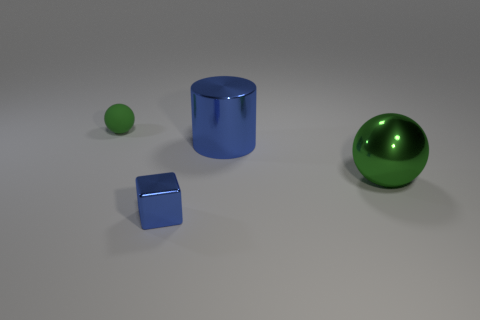What number of objects are cylinders or blue objects to the right of the blue metallic block?
Your response must be concise. 1. There is a object to the left of the blue cube; are there any green metallic spheres that are to the right of it?
Provide a succinct answer. Yes. What color is the sphere that is to the left of the big green thing?
Make the answer very short. Green. Is the number of green matte objects that are to the right of the blue block the same as the number of metallic things?
Provide a short and direct response. No. What is the shape of the object that is behind the big ball and right of the tiny blue shiny block?
Provide a succinct answer. Cylinder. The other matte object that is the same shape as the big green object is what color?
Your answer should be very brief. Green. Is there any other thing that has the same color as the cylinder?
Your answer should be compact. Yes. What shape is the object to the left of the metal thing that is in front of the ball in front of the tiny ball?
Keep it short and to the point. Sphere. There is a green ball in front of the matte ball; is it the same size as the blue thing behind the large green shiny ball?
Ensure brevity in your answer.  Yes. What number of blue cylinders are the same material as the small blue object?
Ensure brevity in your answer.  1. 